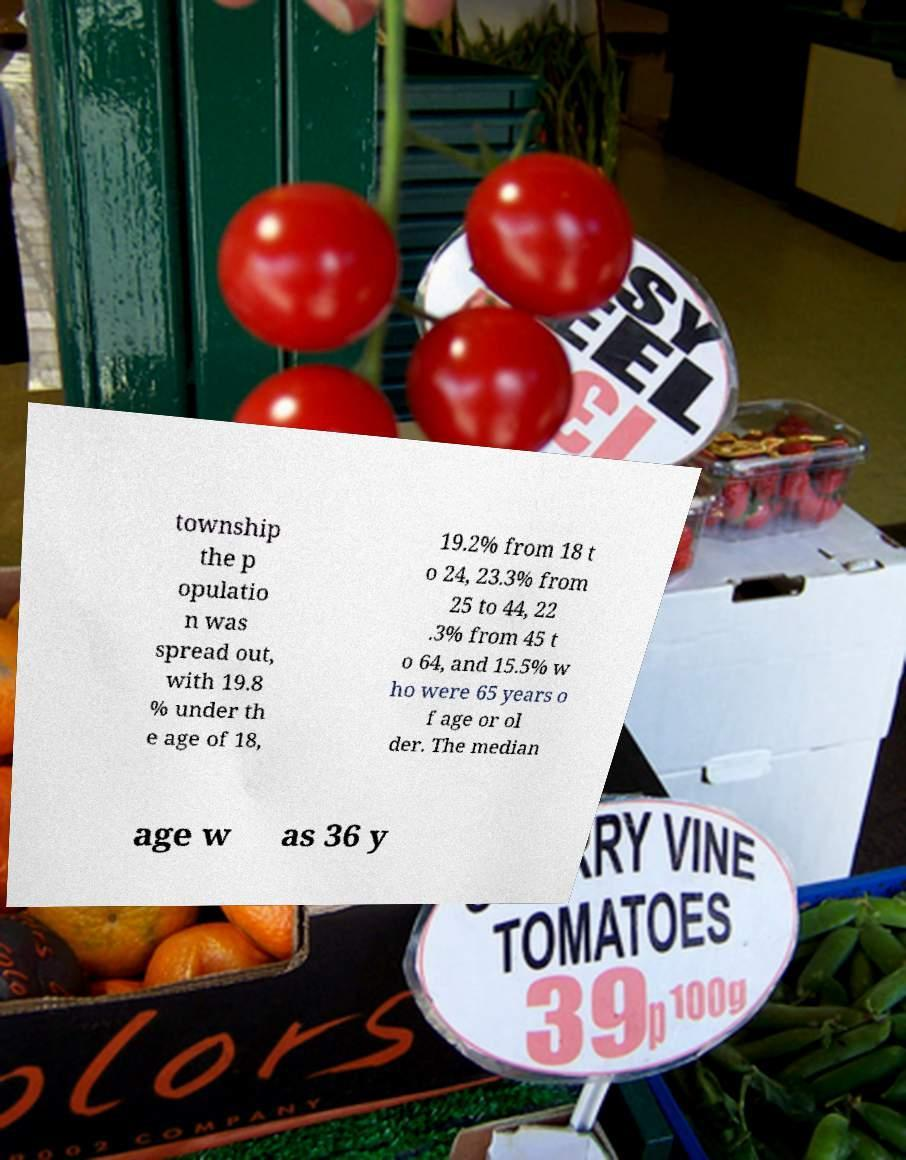I need the written content from this picture converted into text. Can you do that? township the p opulatio n was spread out, with 19.8 % under th e age of 18, 19.2% from 18 t o 24, 23.3% from 25 to 44, 22 .3% from 45 t o 64, and 15.5% w ho were 65 years o f age or ol der. The median age w as 36 y 